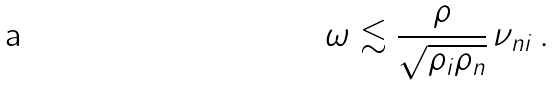<formula> <loc_0><loc_0><loc_500><loc_500>\omega \lesssim \frac { \rho } { \sqrt { \rho _ { i } \rho _ { n } } } \, \nu _ { n i } \, .</formula> 